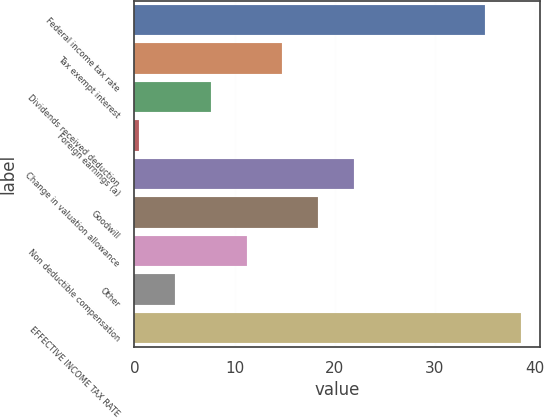<chart> <loc_0><loc_0><loc_500><loc_500><bar_chart><fcel>Federal income tax rate<fcel>Tax exempt interest<fcel>Dividends received deduction<fcel>Foreign earnings (a)<fcel>Change in valuation allowance<fcel>Goodwill<fcel>Non deductible compensation<fcel>Other<fcel>EFFECTIVE INCOME TAX RATE<nl><fcel>35<fcel>14.78<fcel>7.64<fcel>0.5<fcel>21.92<fcel>18.35<fcel>11.21<fcel>4.07<fcel>38.57<nl></chart> 